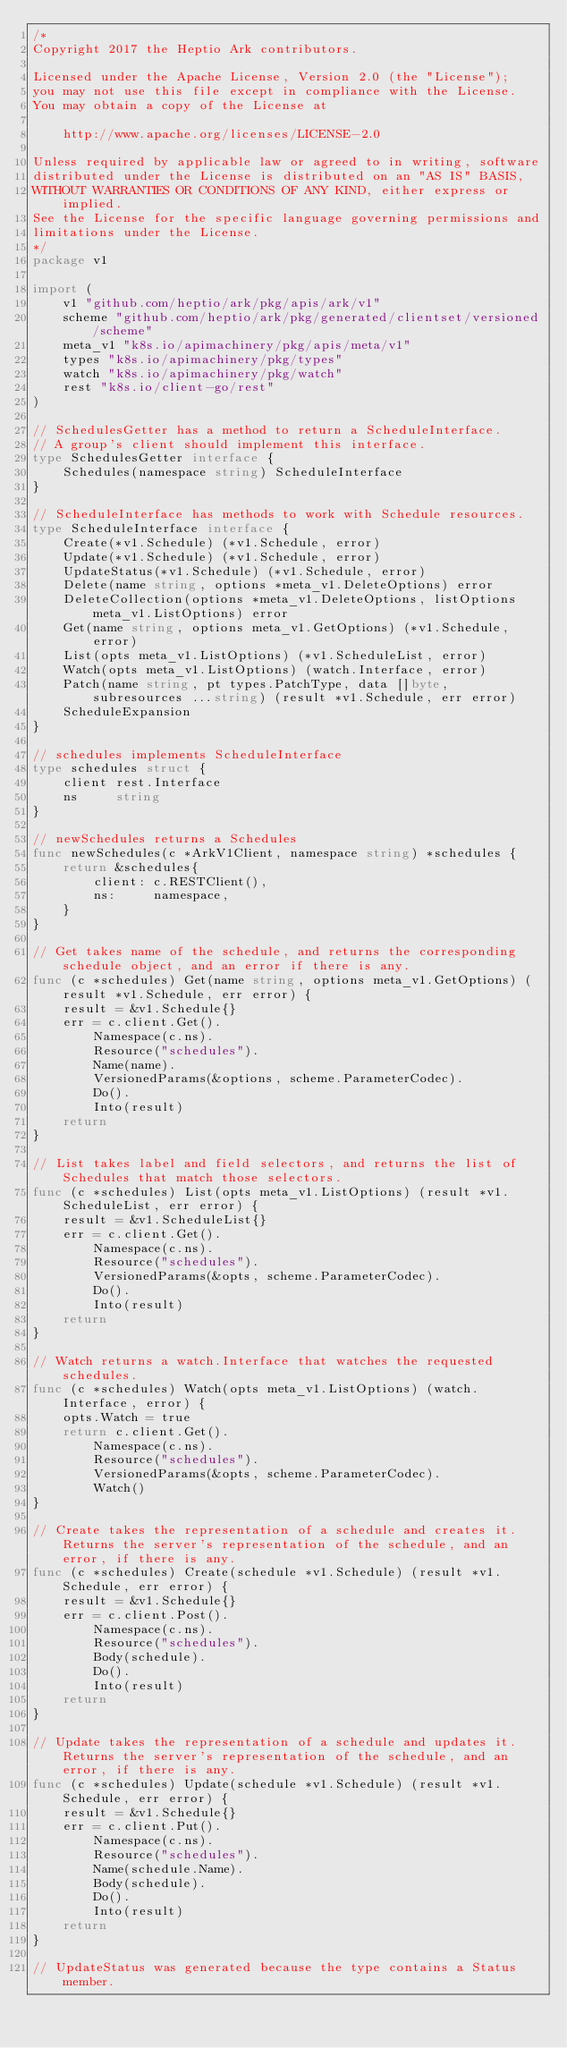Convert code to text. <code><loc_0><loc_0><loc_500><loc_500><_Go_>/*
Copyright 2017 the Heptio Ark contributors.

Licensed under the Apache License, Version 2.0 (the "License");
you may not use this file except in compliance with the License.
You may obtain a copy of the License at

    http://www.apache.org/licenses/LICENSE-2.0

Unless required by applicable law or agreed to in writing, software
distributed under the License is distributed on an "AS IS" BASIS,
WITHOUT WARRANTIES OR CONDITIONS OF ANY KIND, either express or implied.
See the License for the specific language governing permissions and
limitations under the License.
*/
package v1

import (
	v1 "github.com/heptio/ark/pkg/apis/ark/v1"
	scheme "github.com/heptio/ark/pkg/generated/clientset/versioned/scheme"
	meta_v1 "k8s.io/apimachinery/pkg/apis/meta/v1"
	types "k8s.io/apimachinery/pkg/types"
	watch "k8s.io/apimachinery/pkg/watch"
	rest "k8s.io/client-go/rest"
)

// SchedulesGetter has a method to return a ScheduleInterface.
// A group's client should implement this interface.
type SchedulesGetter interface {
	Schedules(namespace string) ScheduleInterface
}

// ScheduleInterface has methods to work with Schedule resources.
type ScheduleInterface interface {
	Create(*v1.Schedule) (*v1.Schedule, error)
	Update(*v1.Schedule) (*v1.Schedule, error)
	UpdateStatus(*v1.Schedule) (*v1.Schedule, error)
	Delete(name string, options *meta_v1.DeleteOptions) error
	DeleteCollection(options *meta_v1.DeleteOptions, listOptions meta_v1.ListOptions) error
	Get(name string, options meta_v1.GetOptions) (*v1.Schedule, error)
	List(opts meta_v1.ListOptions) (*v1.ScheduleList, error)
	Watch(opts meta_v1.ListOptions) (watch.Interface, error)
	Patch(name string, pt types.PatchType, data []byte, subresources ...string) (result *v1.Schedule, err error)
	ScheduleExpansion
}

// schedules implements ScheduleInterface
type schedules struct {
	client rest.Interface
	ns     string
}

// newSchedules returns a Schedules
func newSchedules(c *ArkV1Client, namespace string) *schedules {
	return &schedules{
		client: c.RESTClient(),
		ns:     namespace,
	}
}

// Get takes name of the schedule, and returns the corresponding schedule object, and an error if there is any.
func (c *schedules) Get(name string, options meta_v1.GetOptions) (result *v1.Schedule, err error) {
	result = &v1.Schedule{}
	err = c.client.Get().
		Namespace(c.ns).
		Resource("schedules").
		Name(name).
		VersionedParams(&options, scheme.ParameterCodec).
		Do().
		Into(result)
	return
}

// List takes label and field selectors, and returns the list of Schedules that match those selectors.
func (c *schedules) List(opts meta_v1.ListOptions) (result *v1.ScheduleList, err error) {
	result = &v1.ScheduleList{}
	err = c.client.Get().
		Namespace(c.ns).
		Resource("schedules").
		VersionedParams(&opts, scheme.ParameterCodec).
		Do().
		Into(result)
	return
}

// Watch returns a watch.Interface that watches the requested schedules.
func (c *schedules) Watch(opts meta_v1.ListOptions) (watch.Interface, error) {
	opts.Watch = true
	return c.client.Get().
		Namespace(c.ns).
		Resource("schedules").
		VersionedParams(&opts, scheme.ParameterCodec).
		Watch()
}

// Create takes the representation of a schedule and creates it.  Returns the server's representation of the schedule, and an error, if there is any.
func (c *schedules) Create(schedule *v1.Schedule) (result *v1.Schedule, err error) {
	result = &v1.Schedule{}
	err = c.client.Post().
		Namespace(c.ns).
		Resource("schedules").
		Body(schedule).
		Do().
		Into(result)
	return
}

// Update takes the representation of a schedule and updates it. Returns the server's representation of the schedule, and an error, if there is any.
func (c *schedules) Update(schedule *v1.Schedule) (result *v1.Schedule, err error) {
	result = &v1.Schedule{}
	err = c.client.Put().
		Namespace(c.ns).
		Resource("schedules").
		Name(schedule.Name).
		Body(schedule).
		Do().
		Into(result)
	return
}

// UpdateStatus was generated because the type contains a Status member.</code> 